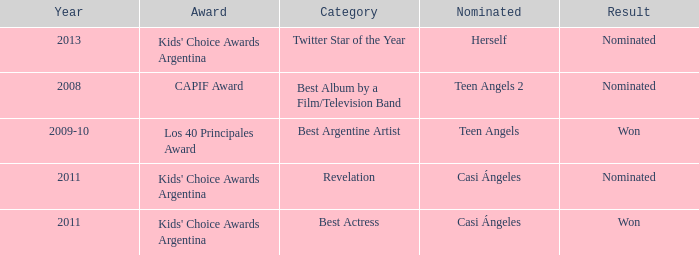What year was Teen Angels 2 nominated? 2008.0. 